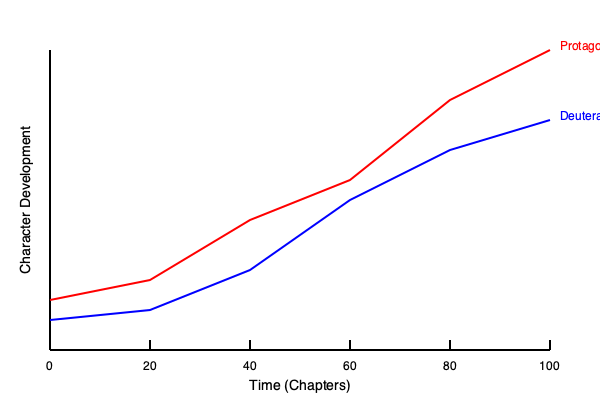Based on the character development timeline graph for a manga series, at which chapter does the deuteragonist's growth rate appear to surpass that of the protagonist? To determine when the deuteragonist's growth rate surpasses the protagonist's, we need to analyze the slopes of their respective lines:

1. The red line represents the protagonist's development.
2. The blue line represents the deuteragonist's development.
3. A steeper slope indicates a faster growth rate.

Let's examine the graph in sections:

1. Chapters 0-20: Both characters show similar, gradual growth.
2. Chapters 20-40: The protagonist's growth accelerates more than the deuteragonist's.
3. Chapters 40-60: The protagonist's growth continues to be faster.
4. Chapters 60-80: The deuteragonist's line becomes steeper than the protagonist's.
5. Chapters 80-100: The deuteragonist's growth rate remains higher than the protagonist's.

The point where the deuteragonist's line becomes steeper than the protagonist's occurs around chapter 60. This is where the blue line's slope increases more sharply compared to the red line, indicating a faster growth rate for the deuteragonist from this point onward.
Answer: Chapter 60 